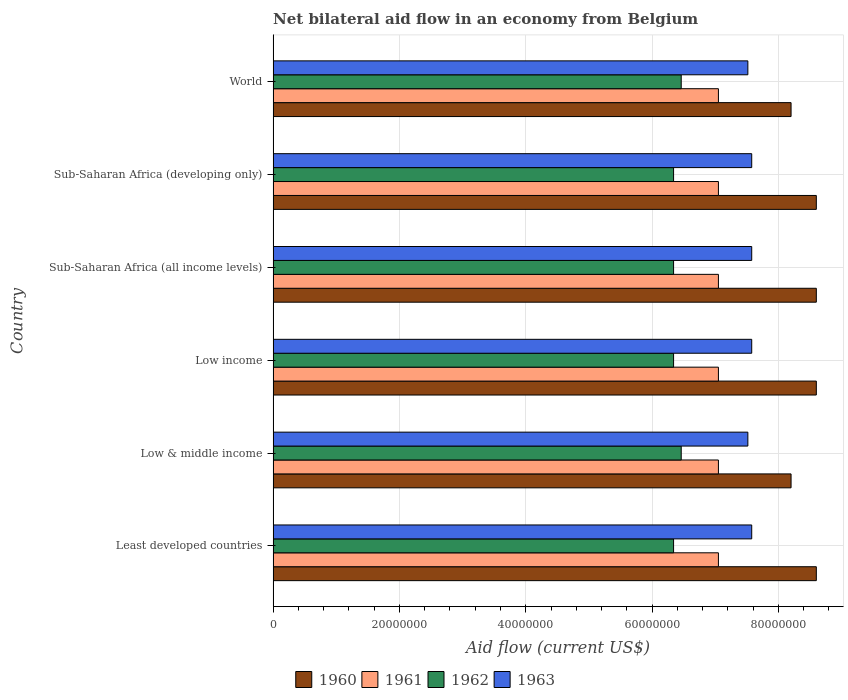How many different coloured bars are there?
Make the answer very short. 4. Are the number of bars per tick equal to the number of legend labels?
Ensure brevity in your answer.  Yes. How many bars are there on the 5th tick from the bottom?
Give a very brief answer. 4. What is the label of the 2nd group of bars from the top?
Ensure brevity in your answer.  Sub-Saharan Africa (developing only). In how many cases, is the number of bars for a given country not equal to the number of legend labels?
Offer a terse response. 0. What is the net bilateral aid flow in 1960 in Low & middle income?
Keep it short and to the point. 8.20e+07. Across all countries, what is the maximum net bilateral aid flow in 1960?
Your response must be concise. 8.60e+07. Across all countries, what is the minimum net bilateral aid flow in 1960?
Provide a short and direct response. 8.20e+07. In which country was the net bilateral aid flow in 1961 maximum?
Make the answer very short. Least developed countries. In which country was the net bilateral aid flow in 1962 minimum?
Your answer should be very brief. Least developed countries. What is the total net bilateral aid flow in 1961 in the graph?
Provide a succinct answer. 4.23e+08. What is the difference between the net bilateral aid flow in 1960 in Least developed countries and the net bilateral aid flow in 1961 in Low income?
Keep it short and to the point. 1.55e+07. What is the average net bilateral aid flow in 1961 per country?
Your answer should be very brief. 7.05e+07. What is the difference between the net bilateral aid flow in 1960 and net bilateral aid flow in 1963 in Sub-Saharan Africa (all income levels)?
Keep it short and to the point. 1.02e+07. In how many countries, is the net bilateral aid flow in 1960 greater than 24000000 US$?
Your response must be concise. 6. Is the net bilateral aid flow in 1963 in Low & middle income less than that in Sub-Saharan Africa (developing only)?
Offer a very short reply. Yes. Is the sum of the net bilateral aid flow in 1963 in Sub-Saharan Africa (developing only) and World greater than the maximum net bilateral aid flow in 1961 across all countries?
Your response must be concise. Yes. What does the 1st bar from the bottom in World represents?
Your answer should be compact. 1960. Is it the case that in every country, the sum of the net bilateral aid flow in 1963 and net bilateral aid flow in 1961 is greater than the net bilateral aid flow in 1960?
Give a very brief answer. Yes. How many bars are there?
Provide a succinct answer. 24. Are all the bars in the graph horizontal?
Provide a short and direct response. Yes. How many countries are there in the graph?
Offer a very short reply. 6. Does the graph contain any zero values?
Ensure brevity in your answer.  No. Where does the legend appear in the graph?
Your response must be concise. Bottom center. How many legend labels are there?
Your answer should be very brief. 4. How are the legend labels stacked?
Offer a terse response. Horizontal. What is the title of the graph?
Your answer should be compact. Net bilateral aid flow in an economy from Belgium. What is the label or title of the Y-axis?
Ensure brevity in your answer.  Country. What is the Aid flow (current US$) in 1960 in Least developed countries?
Ensure brevity in your answer.  8.60e+07. What is the Aid flow (current US$) of 1961 in Least developed countries?
Offer a terse response. 7.05e+07. What is the Aid flow (current US$) in 1962 in Least developed countries?
Give a very brief answer. 6.34e+07. What is the Aid flow (current US$) of 1963 in Least developed countries?
Provide a short and direct response. 7.58e+07. What is the Aid flow (current US$) in 1960 in Low & middle income?
Provide a succinct answer. 8.20e+07. What is the Aid flow (current US$) of 1961 in Low & middle income?
Keep it short and to the point. 7.05e+07. What is the Aid flow (current US$) in 1962 in Low & middle income?
Give a very brief answer. 6.46e+07. What is the Aid flow (current US$) in 1963 in Low & middle income?
Your answer should be compact. 7.52e+07. What is the Aid flow (current US$) in 1960 in Low income?
Keep it short and to the point. 8.60e+07. What is the Aid flow (current US$) in 1961 in Low income?
Give a very brief answer. 7.05e+07. What is the Aid flow (current US$) in 1962 in Low income?
Your answer should be very brief. 6.34e+07. What is the Aid flow (current US$) in 1963 in Low income?
Provide a short and direct response. 7.58e+07. What is the Aid flow (current US$) of 1960 in Sub-Saharan Africa (all income levels)?
Offer a very short reply. 8.60e+07. What is the Aid flow (current US$) of 1961 in Sub-Saharan Africa (all income levels)?
Keep it short and to the point. 7.05e+07. What is the Aid flow (current US$) in 1962 in Sub-Saharan Africa (all income levels)?
Offer a terse response. 6.34e+07. What is the Aid flow (current US$) of 1963 in Sub-Saharan Africa (all income levels)?
Your answer should be very brief. 7.58e+07. What is the Aid flow (current US$) in 1960 in Sub-Saharan Africa (developing only)?
Your response must be concise. 8.60e+07. What is the Aid flow (current US$) in 1961 in Sub-Saharan Africa (developing only)?
Offer a very short reply. 7.05e+07. What is the Aid flow (current US$) of 1962 in Sub-Saharan Africa (developing only)?
Provide a short and direct response. 6.34e+07. What is the Aid flow (current US$) of 1963 in Sub-Saharan Africa (developing only)?
Provide a succinct answer. 7.58e+07. What is the Aid flow (current US$) in 1960 in World?
Ensure brevity in your answer.  8.20e+07. What is the Aid flow (current US$) in 1961 in World?
Provide a succinct answer. 7.05e+07. What is the Aid flow (current US$) in 1962 in World?
Make the answer very short. 6.46e+07. What is the Aid flow (current US$) in 1963 in World?
Make the answer very short. 7.52e+07. Across all countries, what is the maximum Aid flow (current US$) of 1960?
Offer a very short reply. 8.60e+07. Across all countries, what is the maximum Aid flow (current US$) in 1961?
Provide a succinct answer. 7.05e+07. Across all countries, what is the maximum Aid flow (current US$) in 1962?
Your response must be concise. 6.46e+07. Across all countries, what is the maximum Aid flow (current US$) in 1963?
Your answer should be very brief. 7.58e+07. Across all countries, what is the minimum Aid flow (current US$) in 1960?
Make the answer very short. 8.20e+07. Across all countries, what is the minimum Aid flow (current US$) of 1961?
Provide a succinct answer. 7.05e+07. Across all countries, what is the minimum Aid flow (current US$) of 1962?
Offer a terse response. 6.34e+07. Across all countries, what is the minimum Aid flow (current US$) of 1963?
Ensure brevity in your answer.  7.52e+07. What is the total Aid flow (current US$) in 1960 in the graph?
Offer a terse response. 5.08e+08. What is the total Aid flow (current US$) in 1961 in the graph?
Offer a terse response. 4.23e+08. What is the total Aid flow (current US$) in 1962 in the graph?
Ensure brevity in your answer.  3.83e+08. What is the total Aid flow (current US$) of 1963 in the graph?
Give a very brief answer. 4.53e+08. What is the difference between the Aid flow (current US$) in 1962 in Least developed countries and that in Low & middle income?
Offer a very short reply. -1.21e+06. What is the difference between the Aid flow (current US$) of 1963 in Least developed countries and that in Low & middle income?
Give a very brief answer. 6.10e+05. What is the difference between the Aid flow (current US$) in 1960 in Least developed countries and that in Low income?
Make the answer very short. 0. What is the difference between the Aid flow (current US$) in 1961 in Least developed countries and that in Low income?
Your answer should be compact. 0. What is the difference between the Aid flow (current US$) of 1962 in Least developed countries and that in Low income?
Your answer should be compact. 0. What is the difference between the Aid flow (current US$) of 1963 in Least developed countries and that in Low income?
Offer a very short reply. 0. What is the difference between the Aid flow (current US$) of 1960 in Least developed countries and that in Sub-Saharan Africa (all income levels)?
Keep it short and to the point. 0. What is the difference between the Aid flow (current US$) in 1962 in Least developed countries and that in Sub-Saharan Africa (all income levels)?
Keep it short and to the point. 0. What is the difference between the Aid flow (current US$) of 1963 in Least developed countries and that in Sub-Saharan Africa (all income levels)?
Offer a terse response. 0. What is the difference between the Aid flow (current US$) in 1960 in Least developed countries and that in Sub-Saharan Africa (developing only)?
Your answer should be very brief. 0. What is the difference between the Aid flow (current US$) of 1961 in Least developed countries and that in Sub-Saharan Africa (developing only)?
Provide a succinct answer. 0. What is the difference between the Aid flow (current US$) in 1962 in Least developed countries and that in Sub-Saharan Africa (developing only)?
Your answer should be compact. 0. What is the difference between the Aid flow (current US$) of 1961 in Least developed countries and that in World?
Provide a succinct answer. 0. What is the difference between the Aid flow (current US$) of 1962 in Least developed countries and that in World?
Keep it short and to the point. -1.21e+06. What is the difference between the Aid flow (current US$) of 1961 in Low & middle income and that in Low income?
Offer a terse response. 0. What is the difference between the Aid flow (current US$) of 1962 in Low & middle income and that in Low income?
Your answer should be very brief. 1.21e+06. What is the difference between the Aid flow (current US$) in 1963 in Low & middle income and that in Low income?
Your answer should be compact. -6.10e+05. What is the difference between the Aid flow (current US$) in 1961 in Low & middle income and that in Sub-Saharan Africa (all income levels)?
Your answer should be very brief. 0. What is the difference between the Aid flow (current US$) of 1962 in Low & middle income and that in Sub-Saharan Africa (all income levels)?
Ensure brevity in your answer.  1.21e+06. What is the difference between the Aid flow (current US$) of 1963 in Low & middle income and that in Sub-Saharan Africa (all income levels)?
Provide a succinct answer. -6.10e+05. What is the difference between the Aid flow (current US$) of 1961 in Low & middle income and that in Sub-Saharan Africa (developing only)?
Your answer should be very brief. 0. What is the difference between the Aid flow (current US$) of 1962 in Low & middle income and that in Sub-Saharan Africa (developing only)?
Make the answer very short. 1.21e+06. What is the difference between the Aid flow (current US$) in 1963 in Low & middle income and that in Sub-Saharan Africa (developing only)?
Make the answer very short. -6.10e+05. What is the difference between the Aid flow (current US$) of 1960 in Low income and that in Sub-Saharan Africa (all income levels)?
Your answer should be compact. 0. What is the difference between the Aid flow (current US$) in 1961 in Low income and that in Sub-Saharan Africa (all income levels)?
Ensure brevity in your answer.  0. What is the difference between the Aid flow (current US$) of 1962 in Low income and that in Sub-Saharan Africa (all income levels)?
Provide a succinct answer. 0. What is the difference between the Aid flow (current US$) in 1960 in Low income and that in Sub-Saharan Africa (developing only)?
Your answer should be compact. 0. What is the difference between the Aid flow (current US$) in 1961 in Low income and that in Sub-Saharan Africa (developing only)?
Your answer should be compact. 0. What is the difference between the Aid flow (current US$) of 1963 in Low income and that in Sub-Saharan Africa (developing only)?
Provide a succinct answer. 0. What is the difference between the Aid flow (current US$) in 1960 in Low income and that in World?
Provide a succinct answer. 4.00e+06. What is the difference between the Aid flow (current US$) in 1961 in Low income and that in World?
Your answer should be compact. 0. What is the difference between the Aid flow (current US$) of 1962 in Low income and that in World?
Make the answer very short. -1.21e+06. What is the difference between the Aid flow (current US$) in 1963 in Low income and that in World?
Make the answer very short. 6.10e+05. What is the difference between the Aid flow (current US$) of 1960 in Sub-Saharan Africa (all income levels) and that in Sub-Saharan Africa (developing only)?
Ensure brevity in your answer.  0. What is the difference between the Aid flow (current US$) of 1963 in Sub-Saharan Africa (all income levels) and that in Sub-Saharan Africa (developing only)?
Ensure brevity in your answer.  0. What is the difference between the Aid flow (current US$) of 1960 in Sub-Saharan Africa (all income levels) and that in World?
Provide a succinct answer. 4.00e+06. What is the difference between the Aid flow (current US$) in 1961 in Sub-Saharan Africa (all income levels) and that in World?
Provide a succinct answer. 0. What is the difference between the Aid flow (current US$) in 1962 in Sub-Saharan Africa (all income levels) and that in World?
Provide a succinct answer. -1.21e+06. What is the difference between the Aid flow (current US$) of 1963 in Sub-Saharan Africa (all income levels) and that in World?
Your response must be concise. 6.10e+05. What is the difference between the Aid flow (current US$) in 1960 in Sub-Saharan Africa (developing only) and that in World?
Keep it short and to the point. 4.00e+06. What is the difference between the Aid flow (current US$) in 1962 in Sub-Saharan Africa (developing only) and that in World?
Your response must be concise. -1.21e+06. What is the difference between the Aid flow (current US$) in 1963 in Sub-Saharan Africa (developing only) and that in World?
Make the answer very short. 6.10e+05. What is the difference between the Aid flow (current US$) of 1960 in Least developed countries and the Aid flow (current US$) of 1961 in Low & middle income?
Your response must be concise. 1.55e+07. What is the difference between the Aid flow (current US$) of 1960 in Least developed countries and the Aid flow (current US$) of 1962 in Low & middle income?
Provide a succinct answer. 2.14e+07. What is the difference between the Aid flow (current US$) of 1960 in Least developed countries and the Aid flow (current US$) of 1963 in Low & middle income?
Your answer should be very brief. 1.08e+07. What is the difference between the Aid flow (current US$) in 1961 in Least developed countries and the Aid flow (current US$) in 1962 in Low & middle income?
Ensure brevity in your answer.  5.89e+06. What is the difference between the Aid flow (current US$) in 1961 in Least developed countries and the Aid flow (current US$) in 1963 in Low & middle income?
Make the answer very short. -4.66e+06. What is the difference between the Aid flow (current US$) in 1962 in Least developed countries and the Aid flow (current US$) in 1963 in Low & middle income?
Provide a short and direct response. -1.18e+07. What is the difference between the Aid flow (current US$) of 1960 in Least developed countries and the Aid flow (current US$) of 1961 in Low income?
Give a very brief answer. 1.55e+07. What is the difference between the Aid flow (current US$) in 1960 in Least developed countries and the Aid flow (current US$) in 1962 in Low income?
Your response must be concise. 2.26e+07. What is the difference between the Aid flow (current US$) in 1960 in Least developed countries and the Aid flow (current US$) in 1963 in Low income?
Your answer should be very brief. 1.02e+07. What is the difference between the Aid flow (current US$) in 1961 in Least developed countries and the Aid flow (current US$) in 1962 in Low income?
Offer a terse response. 7.10e+06. What is the difference between the Aid flow (current US$) in 1961 in Least developed countries and the Aid flow (current US$) in 1963 in Low income?
Your answer should be very brief. -5.27e+06. What is the difference between the Aid flow (current US$) in 1962 in Least developed countries and the Aid flow (current US$) in 1963 in Low income?
Ensure brevity in your answer.  -1.24e+07. What is the difference between the Aid flow (current US$) of 1960 in Least developed countries and the Aid flow (current US$) of 1961 in Sub-Saharan Africa (all income levels)?
Make the answer very short. 1.55e+07. What is the difference between the Aid flow (current US$) of 1960 in Least developed countries and the Aid flow (current US$) of 1962 in Sub-Saharan Africa (all income levels)?
Offer a very short reply. 2.26e+07. What is the difference between the Aid flow (current US$) in 1960 in Least developed countries and the Aid flow (current US$) in 1963 in Sub-Saharan Africa (all income levels)?
Your response must be concise. 1.02e+07. What is the difference between the Aid flow (current US$) in 1961 in Least developed countries and the Aid flow (current US$) in 1962 in Sub-Saharan Africa (all income levels)?
Offer a very short reply. 7.10e+06. What is the difference between the Aid flow (current US$) of 1961 in Least developed countries and the Aid flow (current US$) of 1963 in Sub-Saharan Africa (all income levels)?
Ensure brevity in your answer.  -5.27e+06. What is the difference between the Aid flow (current US$) in 1962 in Least developed countries and the Aid flow (current US$) in 1963 in Sub-Saharan Africa (all income levels)?
Your answer should be compact. -1.24e+07. What is the difference between the Aid flow (current US$) in 1960 in Least developed countries and the Aid flow (current US$) in 1961 in Sub-Saharan Africa (developing only)?
Offer a very short reply. 1.55e+07. What is the difference between the Aid flow (current US$) in 1960 in Least developed countries and the Aid flow (current US$) in 1962 in Sub-Saharan Africa (developing only)?
Your answer should be compact. 2.26e+07. What is the difference between the Aid flow (current US$) in 1960 in Least developed countries and the Aid flow (current US$) in 1963 in Sub-Saharan Africa (developing only)?
Your answer should be very brief. 1.02e+07. What is the difference between the Aid flow (current US$) in 1961 in Least developed countries and the Aid flow (current US$) in 1962 in Sub-Saharan Africa (developing only)?
Offer a very short reply. 7.10e+06. What is the difference between the Aid flow (current US$) in 1961 in Least developed countries and the Aid flow (current US$) in 1963 in Sub-Saharan Africa (developing only)?
Keep it short and to the point. -5.27e+06. What is the difference between the Aid flow (current US$) in 1962 in Least developed countries and the Aid flow (current US$) in 1963 in Sub-Saharan Africa (developing only)?
Your response must be concise. -1.24e+07. What is the difference between the Aid flow (current US$) of 1960 in Least developed countries and the Aid flow (current US$) of 1961 in World?
Provide a short and direct response. 1.55e+07. What is the difference between the Aid flow (current US$) of 1960 in Least developed countries and the Aid flow (current US$) of 1962 in World?
Provide a succinct answer. 2.14e+07. What is the difference between the Aid flow (current US$) in 1960 in Least developed countries and the Aid flow (current US$) in 1963 in World?
Your response must be concise. 1.08e+07. What is the difference between the Aid flow (current US$) of 1961 in Least developed countries and the Aid flow (current US$) of 1962 in World?
Offer a terse response. 5.89e+06. What is the difference between the Aid flow (current US$) of 1961 in Least developed countries and the Aid flow (current US$) of 1963 in World?
Offer a terse response. -4.66e+06. What is the difference between the Aid flow (current US$) in 1962 in Least developed countries and the Aid flow (current US$) in 1963 in World?
Keep it short and to the point. -1.18e+07. What is the difference between the Aid flow (current US$) in 1960 in Low & middle income and the Aid flow (current US$) in 1961 in Low income?
Give a very brief answer. 1.15e+07. What is the difference between the Aid flow (current US$) of 1960 in Low & middle income and the Aid flow (current US$) of 1962 in Low income?
Offer a very short reply. 1.86e+07. What is the difference between the Aid flow (current US$) in 1960 in Low & middle income and the Aid flow (current US$) in 1963 in Low income?
Your answer should be compact. 6.23e+06. What is the difference between the Aid flow (current US$) of 1961 in Low & middle income and the Aid flow (current US$) of 1962 in Low income?
Offer a very short reply. 7.10e+06. What is the difference between the Aid flow (current US$) of 1961 in Low & middle income and the Aid flow (current US$) of 1963 in Low income?
Provide a short and direct response. -5.27e+06. What is the difference between the Aid flow (current US$) of 1962 in Low & middle income and the Aid flow (current US$) of 1963 in Low income?
Your answer should be compact. -1.12e+07. What is the difference between the Aid flow (current US$) in 1960 in Low & middle income and the Aid flow (current US$) in 1961 in Sub-Saharan Africa (all income levels)?
Offer a very short reply. 1.15e+07. What is the difference between the Aid flow (current US$) in 1960 in Low & middle income and the Aid flow (current US$) in 1962 in Sub-Saharan Africa (all income levels)?
Provide a short and direct response. 1.86e+07. What is the difference between the Aid flow (current US$) in 1960 in Low & middle income and the Aid flow (current US$) in 1963 in Sub-Saharan Africa (all income levels)?
Provide a succinct answer. 6.23e+06. What is the difference between the Aid flow (current US$) in 1961 in Low & middle income and the Aid flow (current US$) in 1962 in Sub-Saharan Africa (all income levels)?
Provide a succinct answer. 7.10e+06. What is the difference between the Aid flow (current US$) of 1961 in Low & middle income and the Aid flow (current US$) of 1963 in Sub-Saharan Africa (all income levels)?
Your response must be concise. -5.27e+06. What is the difference between the Aid flow (current US$) of 1962 in Low & middle income and the Aid flow (current US$) of 1963 in Sub-Saharan Africa (all income levels)?
Provide a short and direct response. -1.12e+07. What is the difference between the Aid flow (current US$) in 1960 in Low & middle income and the Aid flow (current US$) in 1961 in Sub-Saharan Africa (developing only)?
Give a very brief answer. 1.15e+07. What is the difference between the Aid flow (current US$) in 1960 in Low & middle income and the Aid flow (current US$) in 1962 in Sub-Saharan Africa (developing only)?
Provide a succinct answer. 1.86e+07. What is the difference between the Aid flow (current US$) in 1960 in Low & middle income and the Aid flow (current US$) in 1963 in Sub-Saharan Africa (developing only)?
Ensure brevity in your answer.  6.23e+06. What is the difference between the Aid flow (current US$) of 1961 in Low & middle income and the Aid flow (current US$) of 1962 in Sub-Saharan Africa (developing only)?
Keep it short and to the point. 7.10e+06. What is the difference between the Aid flow (current US$) in 1961 in Low & middle income and the Aid flow (current US$) in 1963 in Sub-Saharan Africa (developing only)?
Offer a very short reply. -5.27e+06. What is the difference between the Aid flow (current US$) of 1962 in Low & middle income and the Aid flow (current US$) of 1963 in Sub-Saharan Africa (developing only)?
Keep it short and to the point. -1.12e+07. What is the difference between the Aid flow (current US$) of 1960 in Low & middle income and the Aid flow (current US$) of 1961 in World?
Your response must be concise. 1.15e+07. What is the difference between the Aid flow (current US$) in 1960 in Low & middle income and the Aid flow (current US$) in 1962 in World?
Provide a succinct answer. 1.74e+07. What is the difference between the Aid flow (current US$) in 1960 in Low & middle income and the Aid flow (current US$) in 1963 in World?
Your answer should be very brief. 6.84e+06. What is the difference between the Aid flow (current US$) in 1961 in Low & middle income and the Aid flow (current US$) in 1962 in World?
Your answer should be very brief. 5.89e+06. What is the difference between the Aid flow (current US$) in 1961 in Low & middle income and the Aid flow (current US$) in 1963 in World?
Ensure brevity in your answer.  -4.66e+06. What is the difference between the Aid flow (current US$) of 1962 in Low & middle income and the Aid flow (current US$) of 1963 in World?
Keep it short and to the point. -1.06e+07. What is the difference between the Aid flow (current US$) in 1960 in Low income and the Aid flow (current US$) in 1961 in Sub-Saharan Africa (all income levels)?
Make the answer very short. 1.55e+07. What is the difference between the Aid flow (current US$) of 1960 in Low income and the Aid flow (current US$) of 1962 in Sub-Saharan Africa (all income levels)?
Keep it short and to the point. 2.26e+07. What is the difference between the Aid flow (current US$) of 1960 in Low income and the Aid flow (current US$) of 1963 in Sub-Saharan Africa (all income levels)?
Your response must be concise. 1.02e+07. What is the difference between the Aid flow (current US$) of 1961 in Low income and the Aid flow (current US$) of 1962 in Sub-Saharan Africa (all income levels)?
Offer a very short reply. 7.10e+06. What is the difference between the Aid flow (current US$) of 1961 in Low income and the Aid flow (current US$) of 1963 in Sub-Saharan Africa (all income levels)?
Provide a short and direct response. -5.27e+06. What is the difference between the Aid flow (current US$) of 1962 in Low income and the Aid flow (current US$) of 1963 in Sub-Saharan Africa (all income levels)?
Your answer should be very brief. -1.24e+07. What is the difference between the Aid flow (current US$) in 1960 in Low income and the Aid flow (current US$) in 1961 in Sub-Saharan Africa (developing only)?
Ensure brevity in your answer.  1.55e+07. What is the difference between the Aid flow (current US$) in 1960 in Low income and the Aid flow (current US$) in 1962 in Sub-Saharan Africa (developing only)?
Give a very brief answer. 2.26e+07. What is the difference between the Aid flow (current US$) in 1960 in Low income and the Aid flow (current US$) in 1963 in Sub-Saharan Africa (developing only)?
Your response must be concise. 1.02e+07. What is the difference between the Aid flow (current US$) in 1961 in Low income and the Aid flow (current US$) in 1962 in Sub-Saharan Africa (developing only)?
Offer a very short reply. 7.10e+06. What is the difference between the Aid flow (current US$) in 1961 in Low income and the Aid flow (current US$) in 1963 in Sub-Saharan Africa (developing only)?
Keep it short and to the point. -5.27e+06. What is the difference between the Aid flow (current US$) in 1962 in Low income and the Aid flow (current US$) in 1963 in Sub-Saharan Africa (developing only)?
Provide a short and direct response. -1.24e+07. What is the difference between the Aid flow (current US$) in 1960 in Low income and the Aid flow (current US$) in 1961 in World?
Offer a very short reply. 1.55e+07. What is the difference between the Aid flow (current US$) in 1960 in Low income and the Aid flow (current US$) in 1962 in World?
Ensure brevity in your answer.  2.14e+07. What is the difference between the Aid flow (current US$) in 1960 in Low income and the Aid flow (current US$) in 1963 in World?
Give a very brief answer. 1.08e+07. What is the difference between the Aid flow (current US$) in 1961 in Low income and the Aid flow (current US$) in 1962 in World?
Offer a terse response. 5.89e+06. What is the difference between the Aid flow (current US$) of 1961 in Low income and the Aid flow (current US$) of 1963 in World?
Provide a succinct answer. -4.66e+06. What is the difference between the Aid flow (current US$) in 1962 in Low income and the Aid flow (current US$) in 1963 in World?
Provide a short and direct response. -1.18e+07. What is the difference between the Aid flow (current US$) of 1960 in Sub-Saharan Africa (all income levels) and the Aid flow (current US$) of 1961 in Sub-Saharan Africa (developing only)?
Offer a very short reply. 1.55e+07. What is the difference between the Aid flow (current US$) in 1960 in Sub-Saharan Africa (all income levels) and the Aid flow (current US$) in 1962 in Sub-Saharan Africa (developing only)?
Provide a succinct answer. 2.26e+07. What is the difference between the Aid flow (current US$) of 1960 in Sub-Saharan Africa (all income levels) and the Aid flow (current US$) of 1963 in Sub-Saharan Africa (developing only)?
Provide a succinct answer. 1.02e+07. What is the difference between the Aid flow (current US$) in 1961 in Sub-Saharan Africa (all income levels) and the Aid flow (current US$) in 1962 in Sub-Saharan Africa (developing only)?
Keep it short and to the point. 7.10e+06. What is the difference between the Aid flow (current US$) of 1961 in Sub-Saharan Africa (all income levels) and the Aid flow (current US$) of 1963 in Sub-Saharan Africa (developing only)?
Your answer should be very brief. -5.27e+06. What is the difference between the Aid flow (current US$) of 1962 in Sub-Saharan Africa (all income levels) and the Aid flow (current US$) of 1963 in Sub-Saharan Africa (developing only)?
Keep it short and to the point. -1.24e+07. What is the difference between the Aid flow (current US$) of 1960 in Sub-Saharan Africa (all income levels) and the Aid flow (current US$) of 1961 in World?
Provide a short and direct response. 1.55e+07. What is the difference between the Aid flow (current US$) in 1960 in Sub-Saharan Africa (all income levels) and the Aid flow (current US$) in 1962 in World?
Provide a short and direct response. 2.14e+07. What is the difference between the Aid flow (current US$) of 1960 in Sub-Saharan Africa (all income levels) and the Aid flow (current US$) of 1963 in World?
Provide a short and direct response. 1.08e+07. What is the difference between the Aid flow (current US$) of 1961 in Sub-Saharan Africa (all income levels) and the Aid flow (current US$) of 1962 in World?
Make the answer very short. 5.89e+06. What is the difference between the Aid flow (current US$) in 1961 in Sub-Saharan Africa (all income levels) and the Aid flow (current US$) in 1963 in World?
Your response must be concise. -4.66e+06. What is the difference between the Aid flow (current US$) in 1962 in Sub-Saharan Africa (all income levels) and the Aid flow (current US$) in 1963 in World?
Give a very brief answer. -1.18e+07. What is the difference between the Aid flow (current US$) of 1960 in Sub-Saharan Africa (developing only) and the Aid flow (current US$) of 1961 in World?
Your answer should be compact. 1.55e+07. What is the difference between the Aid flow (current US$) of 1960 in Sub-Saharan Africa (developing only) and the Aid flow (current US$) of 1962 in World?
Offer a terse response. 2.14e+07. What is the difference between the Aid flow (current US$) in 1960 in Sub-Saharan Africa (developing only) and the Aid flow (current US$) in 1963 in World?
Provide a succinct answer. 1.08e+07. What is the difference between the Aid flow (current US$) in 1961 in Sub-Saharan Africa (developing only) and the Aid flow (current US$) in 1962 in World?
Give a very brief answer. 5.89e+06. What is the difference between the Aid flow (current US$) of 1961 in Sub-Saharan Africa (developing only) and the Aid flow (current US$) of 1963 in World?
Keep it short and to the point. -4.66e+06. What is the difference between the Aid flow (current US$) in 1962 in Sub-Saharan Africa (developing only) and the Aid flow (current US$) in 1963 in World?
Your response must be concise. -1.18e+07. What is the average Aid flow (current US$) in 1960 per country?
Ensure brevity in your answer.  8.47e+07. What is the average Aid flow (current US$) of 1961 per country?
Provide a short and direct response. 7.05e+07. What is the average Aid flow (current US$) of 1962 per country?
Give a very brief answer. 6.38e+07. What is the average Aid flow (current US$) in 1963 per country?
Make the answer very short. 7.56e+07. What is the difference between the Aid flow (current US$) of 1960 and Aid flow (current US$) of 1961 in Least developed countries?
Your answer should be very brief. 1.55e+07. What is the difference between the Aid flow (current US$) in 1960 and Aid flow (current US$) in 1962 in Least developed countries?
Your response must be concise. 2.26e+07. What is the difference between the Aid flow (current US$) of 1960 and Aid flow (current US$) of 1963 in Least developed countries?
Make the answer very short. 1.02e+07. What is the difference between the Aid flow (current US$) of 1961 and Aid flow (current US$) of 1962 in Least developed countries?
Keep it short and to the point. 7.10e+06. What is the difference between the Aid flow (current US$) in 1961 and Aid flow (current US$) in 1963 in Least developed countries?
Keep it short and to the point. -5.27e+06. What is the difference between the Aid flow (current US$) of 1962 and Aid flow (current US$) of 1963 in Least developed countries?
Your response must be concise. -1.24e+07. What is the difference between the Aid flow (current US$) of 1960 and Aid flow (current US$) of 1961 in Low & middle income?
Your response must be concise. 1.15e+07. What is the difference between the Aid flow (current US$) in 1960 and Aid flow (current US$) in 1962 in Low & middle income?
Offer a very short reply. 1.74e+07. What is the difference between the Aid flow (current US$) of 1960 and Aid flow (current US$) of 1963 in Low & middle income?
Provide a short and direct response. 6.84e+06. What is the difference between the Aid flow (current US$) in 1961 and Aid flow (current US$) in 1962 in Low & middle income?
Provide a short and direct response. 5.89e+06. What is the difference between the Aid flow (current US$) in 1961 and Aid flow (current US$) in 1963 in Low & middle income?
Your answer should be compact. -4.66e+06. What is the difference between the Aid flow (current US$) of 1962 and Aid flow (current US$) of 1963 in Low & middle income?
Provide a short and direct response. -1.06e+07. What is the difference between the Aid flow (current US$) of 1960 and Aid flow (current US$) of 1961 in Low income?
Your response must be concise. 1.55e+07. What is the difference between the Aid flow (current US$) of 1960 and Aid flow (current US$) of 1962 in Low income?
Give a very brief answer. 2.26e+07. What is the difference between the Aid flow (current US$) in 1960 and Aid flow (current US$) in 1963 in Low income?
Provide a succinct answer. 1.02e+07. What is the difference between the Aid flow (current US$) of 1961 and Aid flow (current US$) of 1962 in Low income?
Provide a short and direct response. 7.10e+06. What is the difference between the Aid flow (current US$) in 1961 and Aid flow (current US$) in 1963 in Low income?
Ensure brevity in your answer.  -5.27e+06. What is the difference between the Aid flow (current US$) of 1962 and Aid flow (current US$) of 1963 in Low income?
Your response must be concise. -1.24e+07. What is the difference between the Aid flow (current US$) in 1960 and Aid flow (current US$) in 1961 in Sub-Saharan Africa (all income levels)?
Ensure brevity in your answer.  1.55e+07. What is the difference between the Aid flow (current US$) of 1960 and Aid flow (current US$) of 1962 in Sub-Saharan Africa (all income levels)?
Give a very brief answer. 2.26e+07. What is the difference between the Aid flow (current US$) of 1960 and Aid flow (current US$) of 1963 in Sub-Saharan Africa (all income levels)?
Your response must be concise. 1.02e+07. What is the difference between the Aid flow (current US$) in 1961 and Aid flow (current US$) in 1962 in Sub-Saharan Africa (all income levels)?
Keep it short and to the point. 7.10e+06. What is the difference between the Aid flow (current US$) in 1961 and Aid flow (current US$) in 1963 in Sub-Saharan Africa (all income levels)?
Offer a very short reply. -5.27e+06. What is the difference between the Aid flow (current US$) in 1962 and Aid flow (current US$) in 1963 in Sub-Saharan Africa (all income levels)?
Your response must be concise. -1.24e+07. What is the difference between the Aid flow (current US$) of 1960 and Aid flow (current US$) of 1961 in Sub-Saharan Africa (developing only)?
Offer a terse response. 1.55e+07. What is the difference between the Aid flow (current US$) of 1960 and Aid flow (current US$) of 1962 in Sub-Saharan Africa (developing only)?
Your answer should be very brief. 2.26e+07. What is the difference between the Aid flow (current US$) in 1960 and Aid flow (current US$) in 1963 in Sub-Saharan Africa (developing only)?
Provide a short and direct response. 1.02e+07. What is the difference between the Aid flow (current US$) of 1961 and Aid flow (current US$) of 1962 in Sub-Saharan Africa (developing only)?
Provide a short and direct response. 7.10e+06. What is the difference between the Aid flow (current US$) in 1961 and Aid flow (current US$) in 1963 in Sub-Saharan Africa (developing only)?
Provide a succinct answer. -5.27e+06. What is the difference between the Aid flow (current US$) in 1962 and Aid flow (current US$) in 1963 in Sub-Saharan Africa (developing only)?
Provide a short and direct response. -1.24e+07. What is the difference between the Aid flow (current US$) in 1960 and Aid flow (current US$) in 1961 in World?
Your answer should be compact. 1.15e+07. What is the difference between the Aid flow (current US$) of 1960 and Aid flow (current US$) of 1962 in World?
Your response must be concise. 1.74e+07. What is the difference between the Aid flow (current US$) in 1960 and Aid flow (current US$) in 1963 in World?
Make the answer very short. 6.84e+06. What is the difference between the Aid flow (current US$) in 1961 and Aid flow (current US$) in 1962 in World?
Make the answer very short. 5.89e+06. What is the difference between the Aid flow (current US$) of 1961 and Aid flow (current US$) of 1963 in World?
Provide a succinct answer. -4.66e+06. What is the difference between the Aid flow (current US$) in 1962 and Aid flow (current US$) in 1963 in World?
Provide a succinct answer. -1.06e+07. What is the ratio of the Aid flow (current US$) in 1960 in Least developed countries to that in Low & middle income?
Provide a succinct answer. 1.05. What is the ratio of the Aid flow (current US$) in 1961 in Least developed countries to that in Low & middle income?
Keep it short and to the point. 1. What is the ratio of the Aid flow (current US$) in 1962 in Least developed countries to that in Low & middle income?
Your answer should be very brief. 0.98. What is the ratio of the Aid flow (current US$) of 1963 in Least developed countries to that in Low & middle income?
Give a very brief answer. 1.01. What is the ratio of the Aid flow (current US$) of 1961 in Least developed countries to that in Low income?
Give a very brief answer. 1. What is the ratio of the Aid flow (current US$) in 1960 in Least developed countries to that in Sub-Saharan Africa (all income levels)?
Give a very brief answer. 1. What is the ratio of the Aid flow (current US$) in 1961 in Least developed countries to that in Sub-Saharan Africa (all income levels)?
Your answer should be very brief. 1. What is the ratio of the Aid flow (current US$) of 1963 in Least developed countries to that in Sub-Saharan Africa (all income levels)?
Provide a succinct answer. 1. What is the ratio of the Aid flow (current US$) in 1962 in Least developed countries to that in Sub-Saharan Africa (developing only)?
Make the answer very short. 1. What is the ratio of the Aid flow (current US$) of 1960 in Least developed countries to that in World?
Provide a succinct answer. 1.05. What is the ratio of the Aid flow (current US$) in 1961 in Least developed countries to that in World?
Offer a terse response. 1. What is the ratio of the Aid flow (current US$) in 1962 in Least developed countries to that in World?
Your answer should be compact. 0.98. What is the ratio of the Aid flow (current US$) in 1960 in Low & middle income to that in Low income?
Keep it short and to the point. 0.95. What is the ratio of the Aid flow (current US$) in 1961 in Low & middle income to that in Low income?
Your response must be concise. 1. What is the ratio of the Aid flow (current US$) in 1962 in Low & middle income to that in Low income?
Offer a very short reply. 1.02. What is the ratio of the Aid flow (current US$) of 1963 in Low & middle income to that in Low income?
Make the answer very short. 0.99. What is the ratio of the Aid flow (current US$) in 1960 in Low & middle income to that in Sub-Saharan Africa (all income levels)?
Make the answer very short. 0.95. What is the ratio of the Aid flow (current US$) of 1961 in Low & middle income to that in Sub-Saharan Africa (all income levels)?
Your response must be concise. 1. What is the ratio of the Aid flow (current US$) in 1962 in Low & middle income to that in Sub-Saharan Africa (all income levels)?
Ensure brevity in your answer.  1.02. What is the ratio of the Aid flow (current US$) of 1963 in Low & middle income to that in Sub-Saharan Africa (all income levels)?
Give a very brief answer. 0.99. What is the ratio of the Aid flow (current US$) in 1960 in Low & middle income to that in Sub-Saharan Africa (developing only)?
Ensure brevity in your answer.  0.95. What is the ratio of the Aid flow (current US$) in 1961 in Low & middle income to that in Sub-Saharan Africa (developing only)?
Ensure brevity in your answer.  1. What is the ratio of the Aid flow (current US$) of 1962 in Low & middle income to that in Sub-Saharan Africa (developing only)?
Keep it short and to the point. 1.02. What is the ratio of the Aid flow (current US$) of 1963 in Low & middle income to that in Sub-Saharan Africa (developing only)?
Your answer should be compact. 0.99. What is the ratio of the Aid flow (current US$) of 1960 in Low & middle income to that in World?
Ensure brevity in your answer.  1. What is the ratio of the Aid flow (current US$) in 1961 in Low & middle income to that in World?
Provide a succinct answer. 1. What is the ratio of the Aid flow (current US$) of 1962 in Low & middle income to that in World?
Your response must be concise. 1. What is the ratio of the Aid flow (current US$) of 1963 in Low & middle income to that in World?
Provide a short and direct response. 1. What is the ratio of the Aid flow (current US$) in 1961 in Low income to that in Sub-Saharan Africa (all income levels)?
Provide a succinct answer. 1. What is the ratio of the Aid flow (current US$) of 1963 in Low income to that in Sub-Saharan Africa (all income levels)?
Offer a terse response. 1. What is the ratio of the Aid flow (current US$) of 1960 in Low income to that in Sub-Saharan Africa (developing only)?
Give a very brief answer. 1. What is the ratio of the Aid flow (current US$) in 1961 in Low income to that in Sub-Saharan Africa (developing only)?
Ensure brevity in your answer.  1. What is the ratio of the Aid flow (current US$) of 1962 in Low income to that in Sub-Saharan Africa (developing only)?
Keep it short and to the point. 1. What is the ratio of the Aid flow (current US$) in 1960 in Low income to that in World?
Provide a short and direct response. 1.05. What is the ratio of the Aid flow (current US$) of 1962 in Low income to that in World?
Keep it short and to the point. 0.98. What is the ratio of the Aid flow (current US$) of 1963 in Low income to that in World?
Provide a short and direct response. 1.01. What is the ratio of the Aid flow (current US$) in 1960 in Sub-Saharan Africa (all income levels) to that in Sub-Saharan Africa (developing only)?
Give a very brief answer. 1. What is the ratio of the Aid flow (current US$) of 1962 in Sub-Saharan Africa (all income levels) to that in Sub-Saharan Africa (developing only)?
Your response must be concise. 1. What is the ratio of the Aid flow (current US$) in 1960 in Sub-Saharan Africa (all income levels) to that in World?
Offer a very short reply. 1.05. What is the ratio of the Aid flow (current US$) of 1962 in Sub-Saharan Africa (all income levels) to that in World?
Provide a succinct answer. 0.98. What is the ratio of the Aid flow (current US$) of 1963 in Sub-Saharan Africa (all income levels) to that in World?
Ensure brevity in your answer.  1.01. What is the ratio of the Aid flow (current US$) of 1960 in Sub-Saharan Africa (developing only) to that in World?
Give a very brief answer. 1.05. What is the ratio of the Aid flow (current US$) in 1962 in Sub-Saharan Africa (developing only) to that in World?
Your answer should be compact. 0.98. What is the difference between the highest and the second highest Aid flow (current US$) of 1960?
Make the answer very short. 0. What is the difference between the highest and the second highest Aid flow (current US$) in 1961?
Provide a short and direct response. 0. What is the difference between the highest and the lowest Aid flow (current US$) of 1962?
Your answer should be compact. 1.21e+06. 